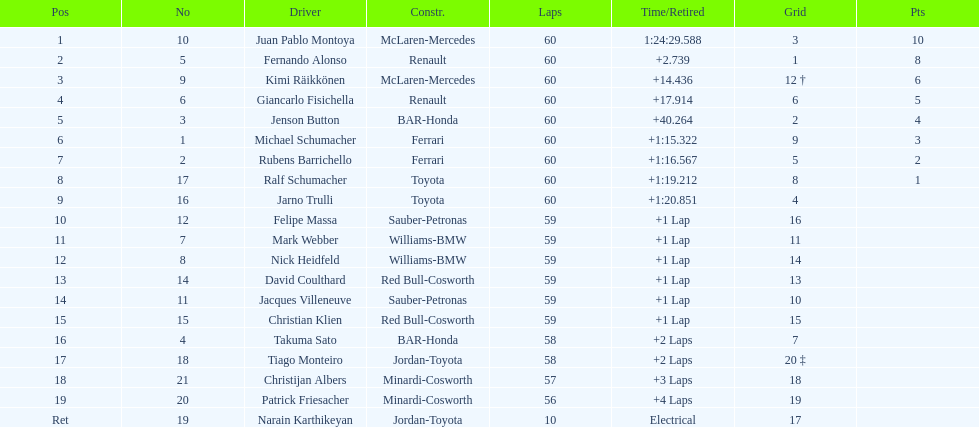Which driver has his grid at 2? Jenson Button. Give me the full table as a dictionary. {'header': ['Pos', 'No', 'Driver', 'Constr.', 'Laps', 'Time/Retired', 'Grid', 'Pts'], 'rows': [['1', '10', 'Juan Pablo Montoya', 'McLaren-Mercedes', '60', '1:24:29.588', '3', '10'], ['2', '5', 'Fernando Alonso', 'Renault', '60', '+2.739', '1', '8'], ['3', '9', 'Kimi Räikkönen', 'McLaren-Mercedes', '60', '+14.436', '12 †', '6'], ['4', '6', 'Giancarlo Fisichella', 'Renault', '60', '+17.914', '6', '5'], ['5', '3', 'Jenson Button', 'BAR-Honda', '60', '+40.264', '2', '4'], ['6', '1', 'Michael Schumacher', 'Ferrari', '60', '+1:15.322', '9', '3'], ['7', '2', 'Rubens Barrichello', 'Ferrari', '60', '+1:16.567', '5', '2'], ['8', '17', 'Ralf Schumacher', 'Toyota', '60', '+1:19.212', '8', '1'], ['9', '16', 'Jarno Trulli', 'Toyota', '60', '+1:20.851', '4', ''], ['10', '12', 'Felipe Massa', 'Sauber-Petronas', '59', '+1 Lap', '16', ''], ['11', '7', 'Mark Webber', 'Williams-BMW', '59', '+1 Lap', '11', ''], ['12', '8', 'Nick Heidfeld', 'Williams-BMW', '59', '+1 Lap', '14', ''], ['13', '14', 'David Coulthard', 'Red Bull-Cosworth', '59', '+1 Lap', '13', ''], ['14', '11', 'Jacques Villeneuve', 'Sauber-Petronas', '59', '+1 Lap', '10', ''], ['15', '15', 'Christian Klien', 'Red Bull-Cosworth', '59', '+1 Lap', '15', ''], ['16', '4', 'Takuma Sato', 'BAR-Honda', '58', '+2 Laps', '7', ''], ['17', '18', 'Tiago Monteiro', 'Jordan-Toyota', '58', '+2 Laps', '20 ‡', ''], ['18', '21', 'Christijan Albers', 'Minardi-Cosworth', '57', '+3 Laps', '18', ''], ['19', '20', 'Patrick Friesacher', 'Minardi-Cosworth', '56', '+4 Laps', '19', ''], ['Ret', '19', 'Narain Karthikeyan', 'Jordan-Toyota', '10', 'Electrical', '17', '']]} 